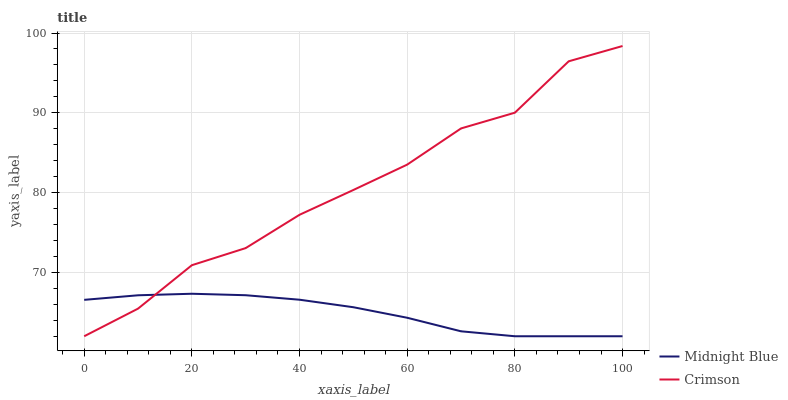Does Midnight Blue have the minimum area under the curve?
Answer yes or no. Yes. Does Crimson have the maximum area under the curve?
Answer yes or no. Yes. Does Midnight Blue have the maximum area under the curve?
Answer yes or no. No. Is Midnight Blue the smoothest?
Answer yes or no. Yes. Is Crimson the roughest?
Answer yes or no. Yes. Is Midnight Blue the roughest?
Answer yes or no. No. Does Crimson have the lowest value?
Answer yes or no. Yes. Does Crimson have the highest value?
Answer yes or no. Yes. Does Midnight Blue have the highest value?
Answer yes or no. No. Does Crimson intersect Midnight Blue?
Answer yes or no. Yes. Is Crimson less than Midnight Blue?
Answer yes or no. No. Is Crimson greater than Midnight Blue?
Answer yes or no. No. 